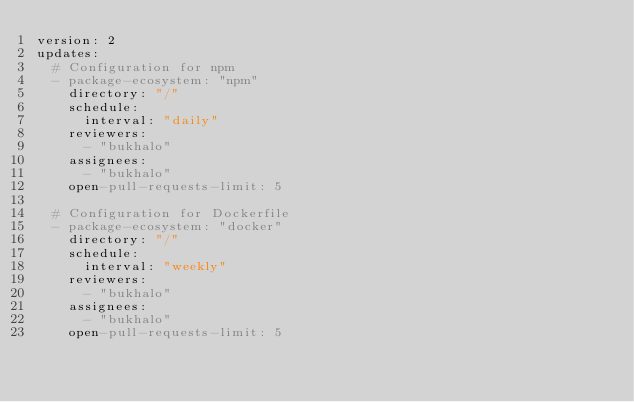Convert code to text. <code><loc_0><loc_0><loc_500><loc_500><_YAML_>version: 2
updates:
  # Configuration for npm
  - package-ecosystem: "npm"
    directory: "/"
    schedule:
      interval: "daily"
    reviewers:
      - "bukhalo"
    assignees:
      - "bukhalo"
    open-pull-requests-limit: 5

  # Configuration for Dockerfile
  - package-ecosystem: "docker"
    directory: "/"
    schedule:
      interval: "weekly"
    reviewers:
      - "bukhalo"
    assignees:
      - "bukhalo"
    open-pull-requests-limit: 5
</code> 